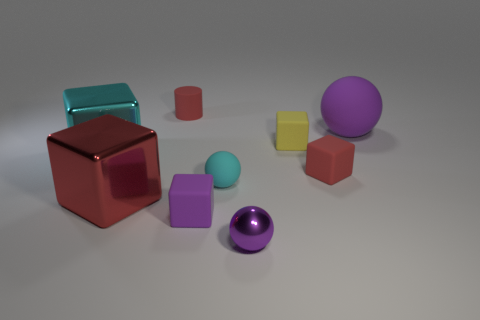Does the small purple shiny thing have the same shape as the small rubber object behind the big sphere?
Your response must be concise. No. What is the shape of the other rubber thing that is the same color as the large matte object?
Your response must be concise. Cube. Are there fewer purple metal spheres behind the small cyan rubber object than large purple balls?
Offer a terse response. Yes. Is the shape of the large purple matte object the same as the cyan matte thing?
Keep it short and to the point. Yes. What is the size of the red block that is made of the same material as the cyan cube?
Keep it short and to the point. Large. Is the number of metal things less than the number of small purple cubes?
Your answer should be compact. No. What number of large objects are matte things or purple matte cubes?
Provide a succinct answer. 1. What number of rubber objects are both in front of the yellow thing and right of the purple metallic ball?
Offer a terse response. 1. Is the number of tiny green cubes greater than the number of small metallic things?
Ensure brevity in your answer.  No. How many other objects are the same shape as the tiny shiny thing?
Your answer should be compact. 2. 